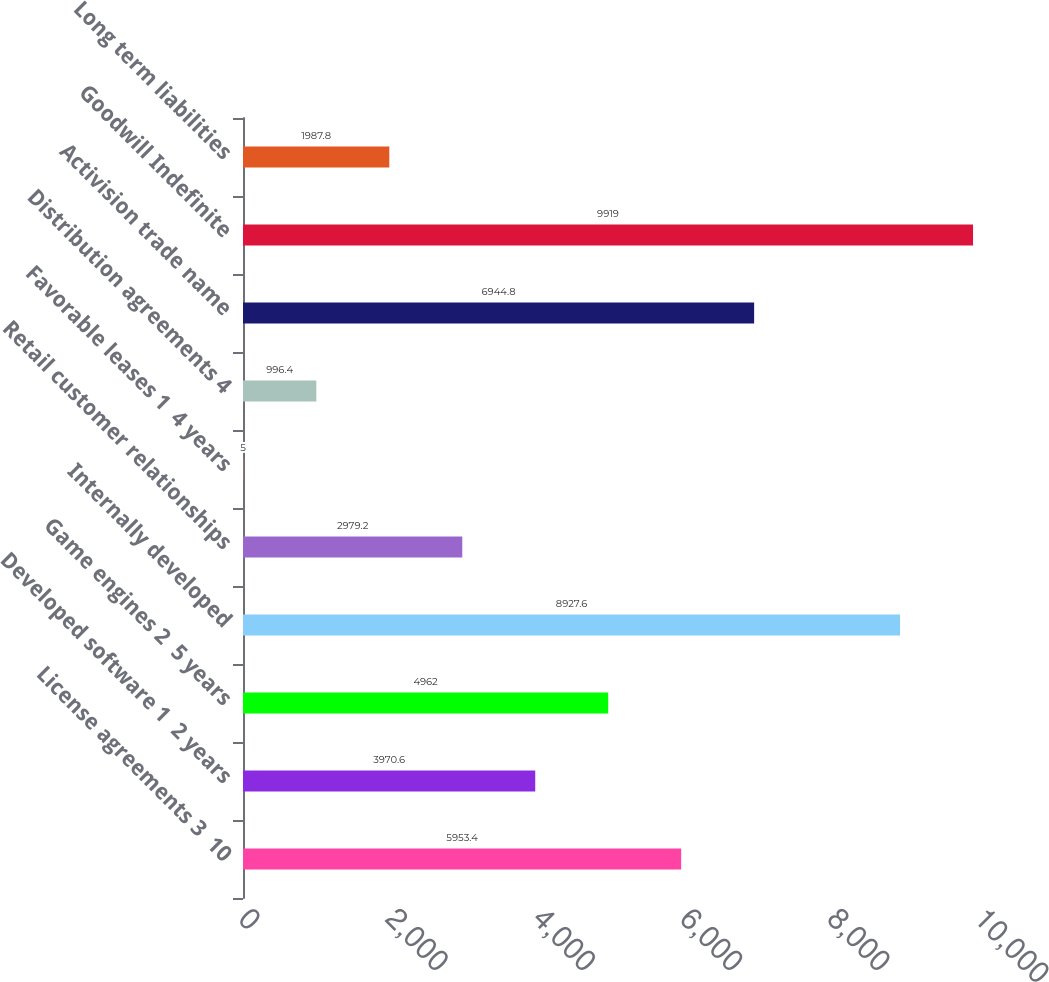Convert chart. <chart><loc_0><loc_0><loc_500><loc_500><bar_chart><fcel>License agreements 3 ­ 10<fcel>Developed software 1 ­ 2 years<fcel>Game engines 2 ­ 5 years<fcel>Internally developed<fcel>Retail customer relationships<fcel>Favorable leases 1 ­ 4 years<fcel>Distribution agreements 4<fcel>Activision trade name<fcel>Goodwill Indefinite<fcel>Long term liabilities<nl><fcel>5953.4<fcel>3970.6<fcel>4962<fcel>8927.6<fcel>2979.2<fcel>5<fcel>996.4<fcel>6944.8<fcel>9919<fcel>1987.8<nl></chart> 